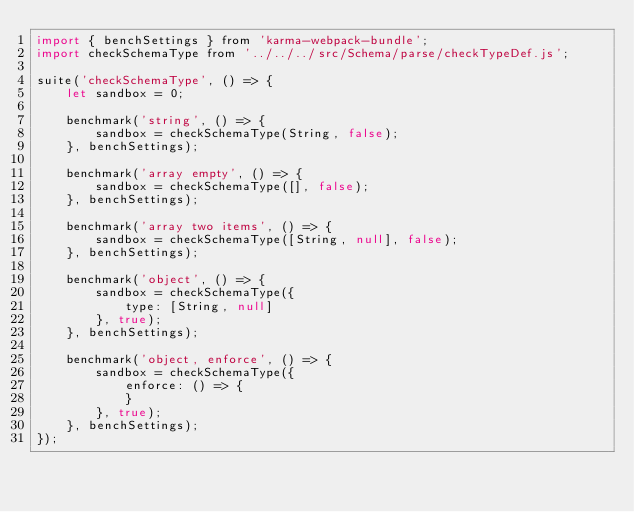<code> <loc_0><loc_0><loc_500><loc_500><_JavaScript_>import { benchSettings } from 'karma-webpack-bundle';
import checkSchemaType from '../../../src/Schema/parse/checkTypeDef.js';

suite('checkSchemaType', () => {
	let sandbox = 0;

	benchmark('string', () => {
		sandbox = checkSchemaType(String, false);
	}, benchSettings);

	benchmark('array empty', () => {
		sandbox = checkSchemaType([], false);
	}, benchSettings);

	benchmark('array two items', () => {
		sandbox = checkSchemaType([String, null], false);
	}, benchSettings);

	benchmark('object', () => {
		sandbox = checkSchemaType({
			type: [String, null]
		}, true);
	}, benchSettings);

	benchmark('object, enforce', () => {
		sandbox = checkSchemaType({
			enforce: () => {
			}
		}, true);
	}, benchSettings);
});
</code> 